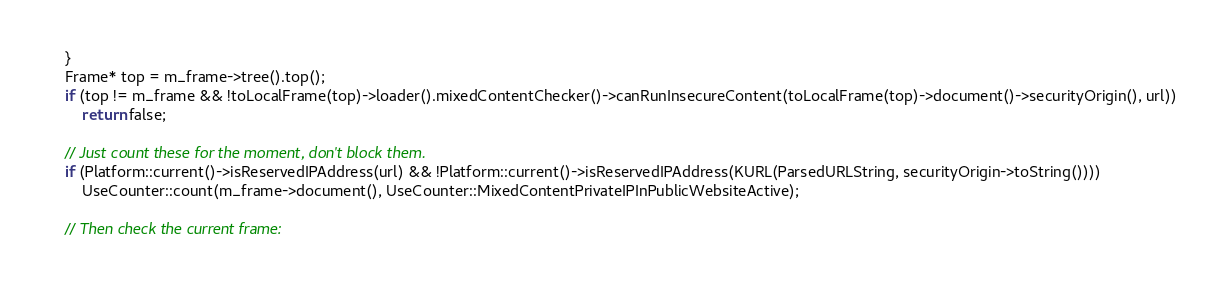<code> <loc_0><loc_0><loc_500><loc_500><_C++_>    }
    Frame* top = m_frame->tree().top();
    if (top != m_frame && !toLocalFrame(top)->loader().mixedContentChecker()->canRunInsecureContent(toLocalFrame(top)->document()->securityOrigin(), url))
        return false;

    // Just count these for the moment, don't block them.
    if (Platform::current()->isReservedIPAddress(url) && !Platform::current()->isReservedIPAddress(KURL(ParsedURLString, securityOrigin->toString())))
        UseCounter::count(m_frame->document(), UseCounter::MixedContentPrivateIPInPublicWebsiteActive);

    // Then check the current frame:</code> 